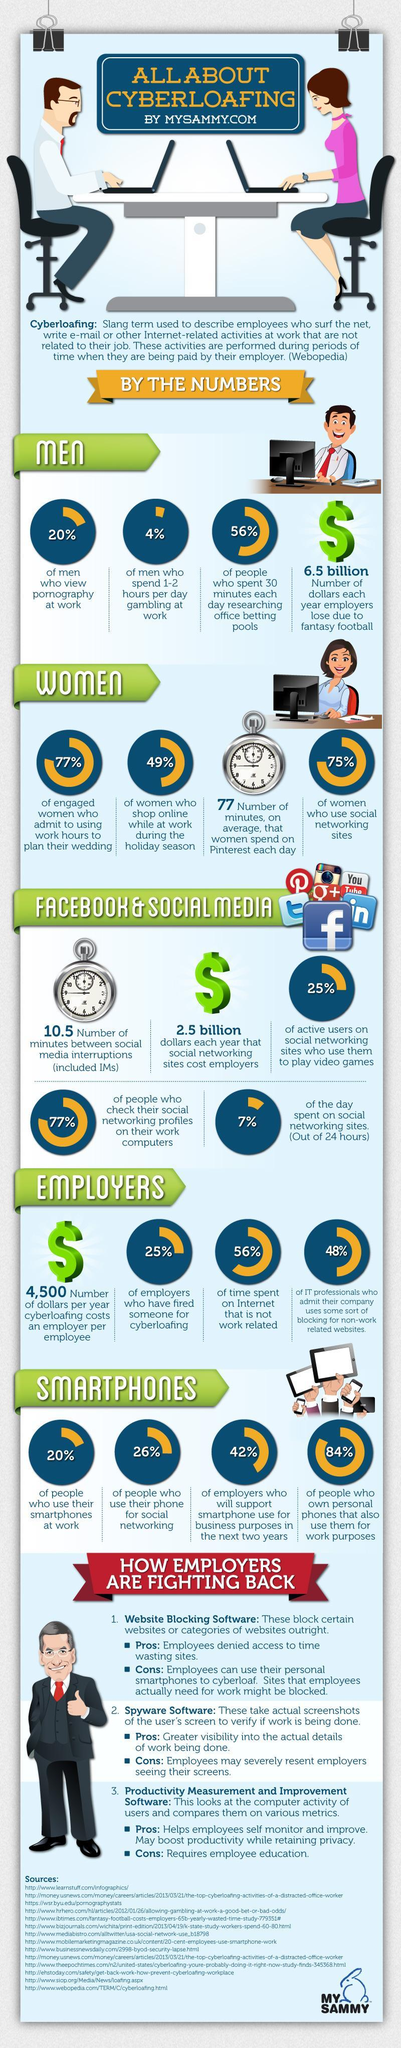How many dollars were lost by the employers each year due to fantasy football?
Answer the question with a short phrase. 6.5 billion What percentage of men view pornography at work? 20% What percentage of women at work do not use social networking sites? 25% What percent of men spend 1-2 hours per day gambling at work? 4% What percentage of women shop online while at work during the holiday season? 49% What percentage of people use smartphones for social networking? 26% What percent of time is spent by the employers on the internet for doing work related things? 44% What percentage of employers have fired someone for cyberloafing? 25% What percentage of people do not use smartphones at work? 80% 